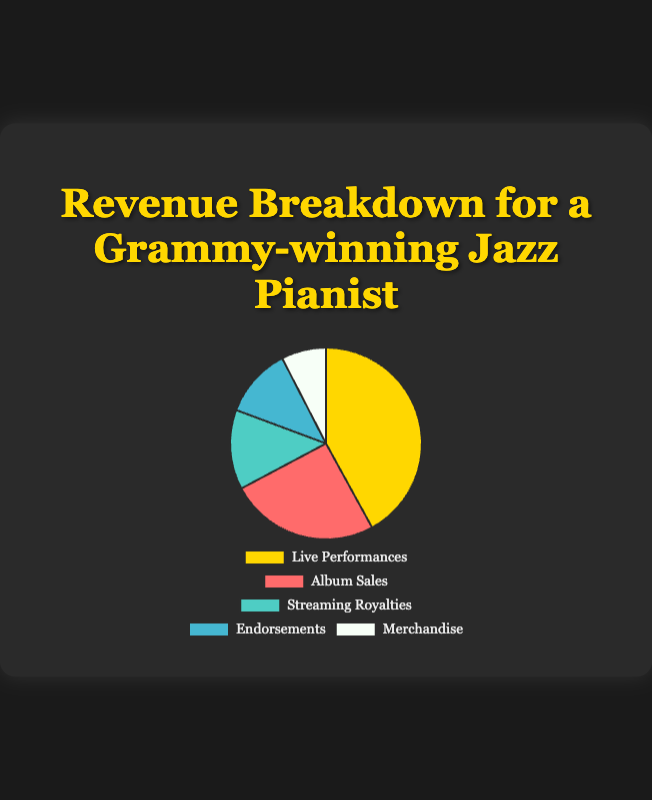What is the largest source of revenue? The pie chart indicates the size of each revenue source. The section representing "Live Performances" is the largest, which indicates it is the largest source of revenue.
Answer: Live Performances How much more revenue is generated by album sales compared to merchandise? According to the data, album sales generate $150,000 and merchandise generates $45,000. The difference is $150,000 - $45,000 = $105,000.
Answer: $105,000 Which revenue source contributes the least? The chart segment that is the smallest represents the least revenue. The "Merchandise" segment is the smallest.
Answer: Merchandise What is the combined revenue from streaming royalties and endorsements? Streaming royalties and endorsements generate $80,000 and $70,000 respectively. Therefore, combined revenue is $80,000 + $70,000 = $150,000.
Answer: $150,000 What percentage of the total revenue comes from live performances? Let's sum all revenues: $150,000 (Album Sales) + $80,000 (Streaming Royalties) + $250,000 (Live Performances) + $45,000 (Merchandise) + $70,000 (Endorsements) = $595,000. The percentage is calculated as ($250,000 / $595,000) * 100.
Answer: 42% Which revenue sources have more than $100,000? The pie chart shows the following revenues: Live Performances ($250,000), Album Sales ($150,000). These values are greater than $100,000.
Answer: Live Performances, Album Sales What is the difference in revenue between the highest-earning and lowest-earning sources? The highest-earning source is live performances ($250,000), and the lowest-earning source is merchandise ($45,000). The difference is $250,000 - $45,000.
Answer: $205,000 What fraction of the total revenue is attributed to endorsements? The total revenue is $595,000. Endorsements contribute $70,000. Therefore, the fraction is $70,000 / $595,000.
Answer: 7/59 Which sources combined make up more than half of the total revenue? First, we need the combined total revenue: $595,000. Half of this is $297,500. "Live Performances" ($250,000) combined with "Album Sales" ($150,000) make $400,000, more than half of the total revenue.
Answer: Live Performances, Album Sales What is the average revenue across all sources? The total revenue is $595,000, and there are 5 sources. The average revenue is $595,000 / 5.
Answer: $119,000 